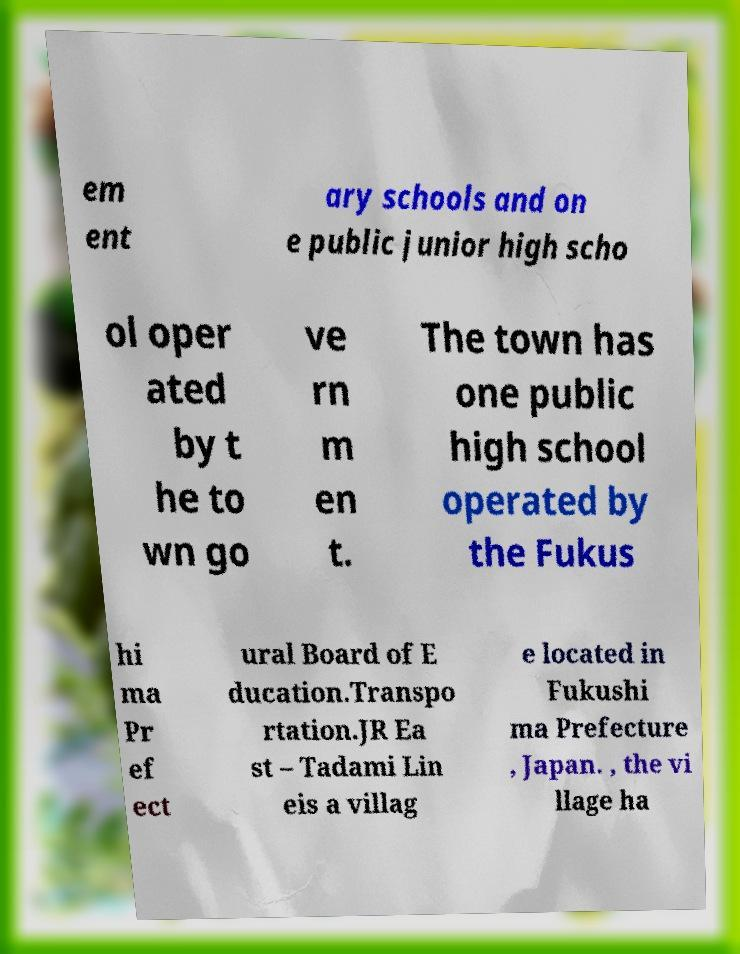Could you extract and type out the text from this image? em ent ary schools and on e public junior high scho ol oper ated by t he to wn go ve rn m en t. The town has one public high school operated by the Fukus hi ma Pr ef ect ural Board of E ducation.Transpo rtation.JR Ea st – Tadami Lin eis a villag e located in Fukushi ma Prefecture , Japan. , the vi llage ha 